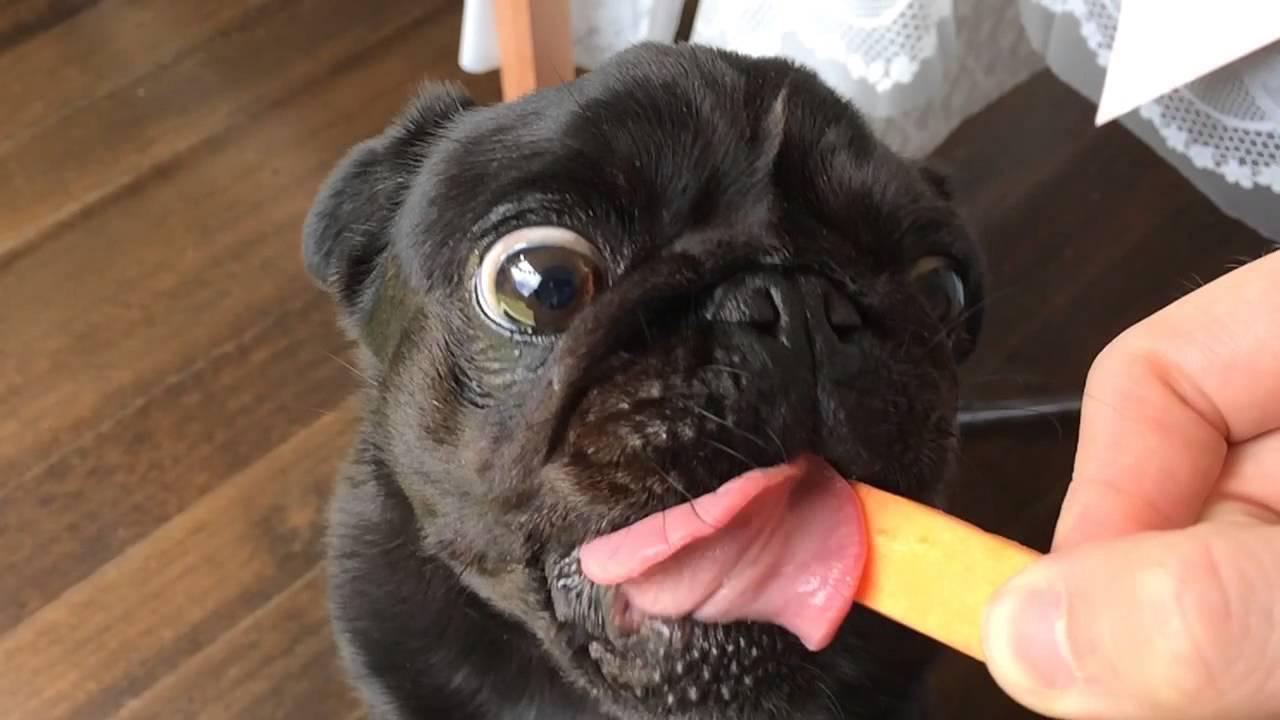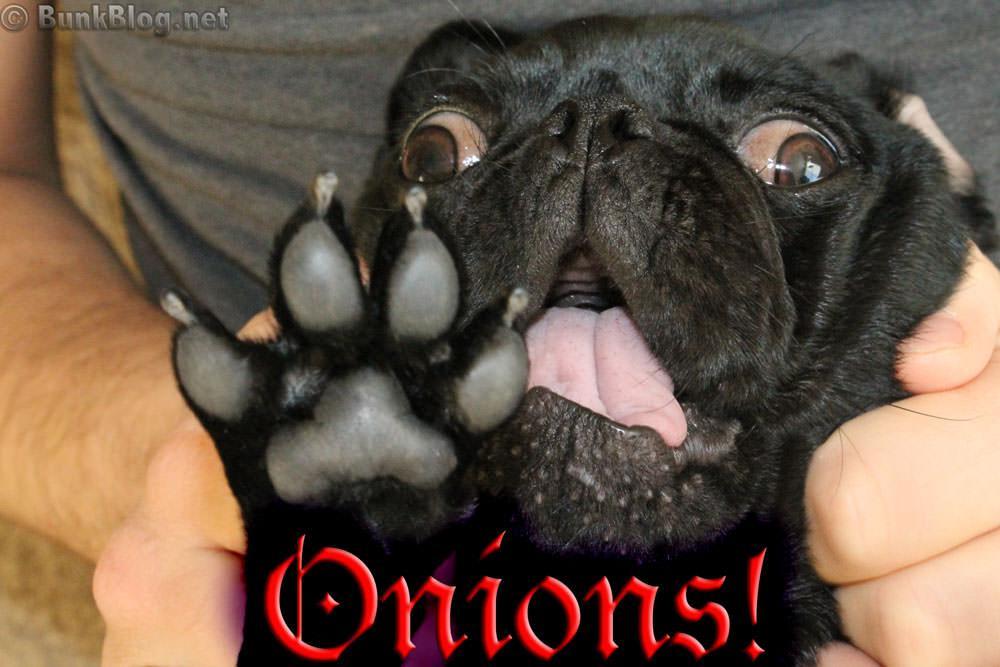The first image is the image on the left, the second image is the image on the right. Evaluate the accuracy of this statement regarding the images: "An image shows a pug dog chomping on watermelon.". Is it true? Answer yes or no. No. The first image is the image on the left, the second image is the image on the right. Evaluate the accuracy of this statement regarding the images: "The dog in the image on the left is eating a chunk of watermelon.". Is it true? Answer yes or no. No. 